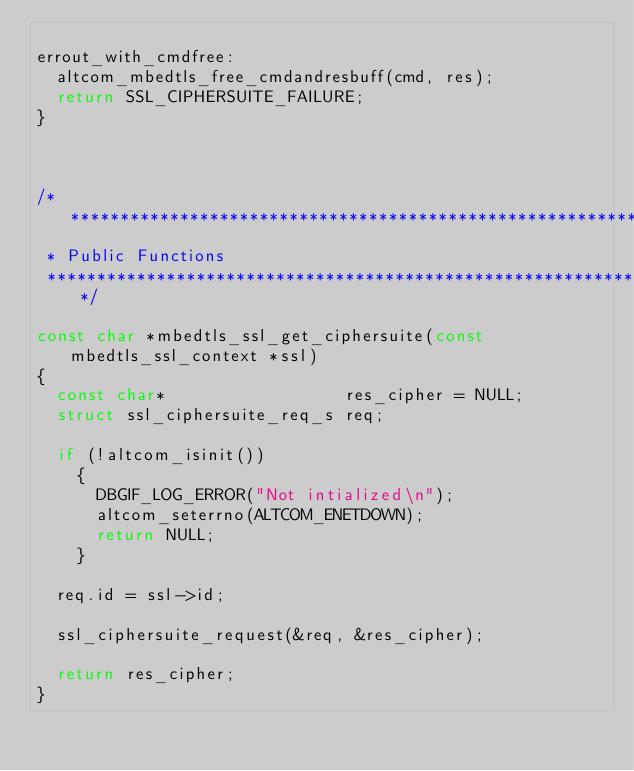<code> <loc_0><loc_0><loc_500><loc_500><_C_>
errout_with_cmdfree:
  altcom_mbedtls_free_cmdandresbuff(cmd, res);
  return SSL_CIPHERSUITE_FAILURE;
}



/****************************************************************************
 * Public Functions
 ****************************************************************************/

const char *mbedtls_ssl_get_ciphersuite(const mbedtls_ssl_context *ssl)
{
  const char*                  res_cipher = NULL;
  struct ssl_ciphersuite_req_s req;

  if (!altcom_isinit())
    {
      DBGIF_LOG_ERROR("Not intialized\n");
      altcom_seterrno(ALTCOM_ENETDOWN);
      return NULL;
    }

  req.id = ssl->id;

  ssl_ciphersuite_request(&req, &res_cipher);

  return res_cipher;
}

</code> 